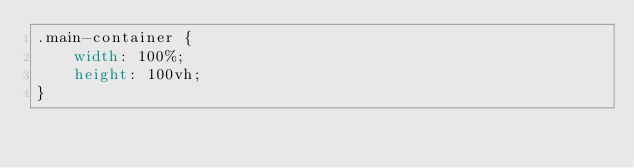Convert code to text. <code><loc_0><loc_0><loc_500><loc_500><_CSS_>.main-container {
    width: 100%;
    height: 100vh;
}</code> 